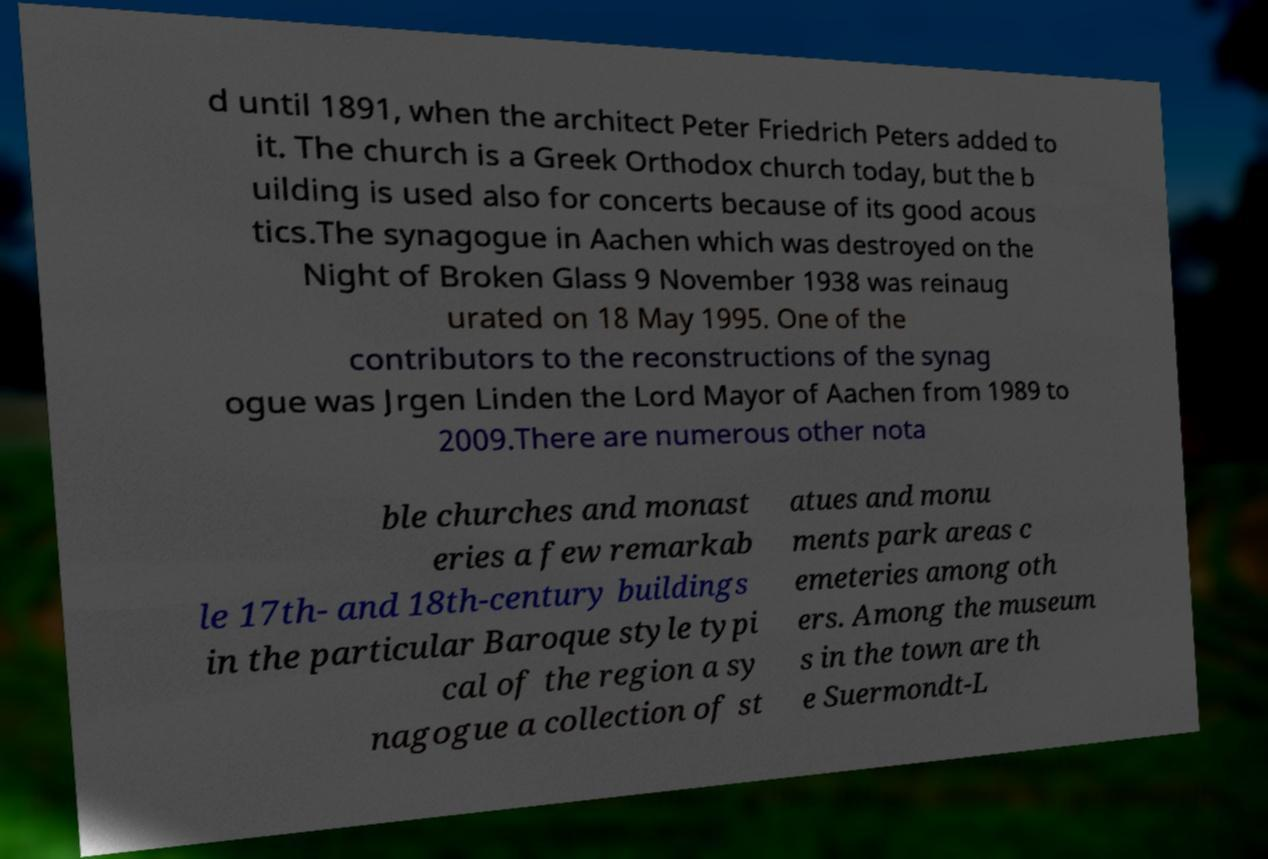What messages or text are displayed in this image? I need them in a readable, typed format. d until 1891, when the architect Peter Friedrich Peters added to it. The church is a Greek Orthodox church today, but the b uilding is used also for concerts because of its good acous tics.The synagogue in Aachen which was destroyed on the Night of Broken Glass 9 November 1938 was reinaug urated on 18 May 1995. One of the contributors to the reconstructions of the synag ogue was Jrgen Linden the Lord Mayor of Aachen from 1989 to 2009.There are numerous other nota ble churches and monast eries a few remarkab le 17th- and 18th-century buildings in the particular Baroque style typi cal of the region a sy nagogue a collection of st atues and monu ments park areas c emeteries among oth ers. Among the museum s in the town are th e Suermondt-L 